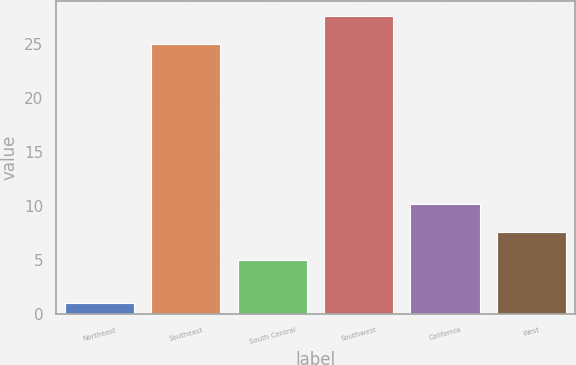Convert chart to OTSL. <chart><loc_0><loc_0><loc_500><loc_500><bar_chart><fcel>Northeast<fcel>Southeast<fcel>South Central<fcel>Southwest<fcel>California<fcel>West<nl><fcel>1<fcel>25<fcel>5<fcel>27.6<fcel>10.2<fcel>7.6<nl></chart> 